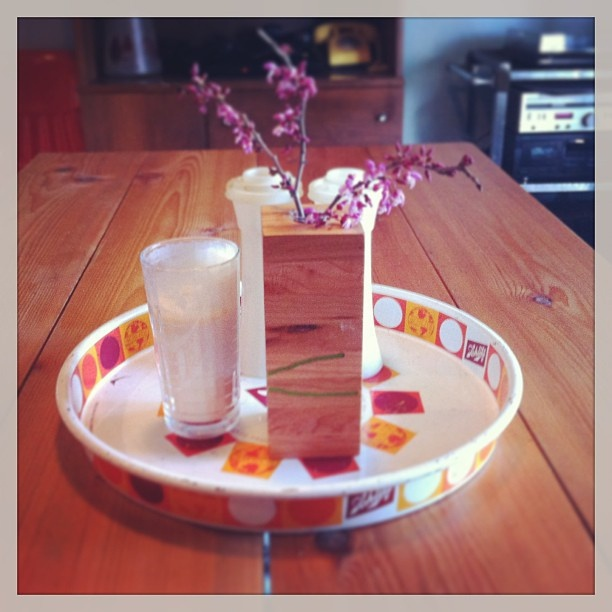Describe the objects in this image and their specific colors. I can see dining table in darkgray, brown, and lightgray tones, potted plant in darkgray, brown, purple, and violet tones, vase in darkgray, brown, tan, and lightpink tones, oven in darkgray, navy, black, ivory, and gray tones, and cup in darkgray, lavender, and lightgray tones in this image. 